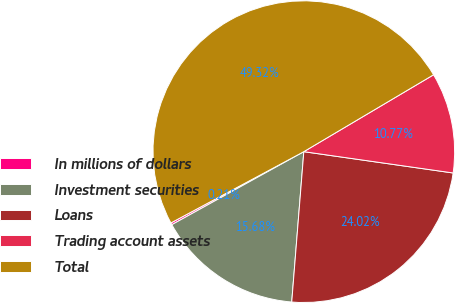Convert chart. <chart><loc_0><loc_0><loc_500><loc_500><pie_chart><fcel>In millions of dollars<fcel>Investment securities<fcel>Loans<fcel>Trading account assets<fcel>Total<nl><fcel>0.21%<fcel>15.68%<fcel>24.02%<fcel>10.77%<fcel>49.32%<nl></chart> 